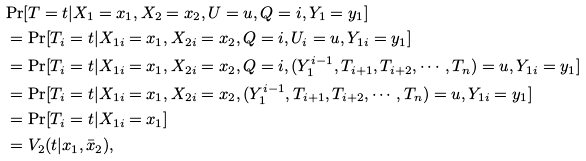<formula> <loc_0><loc_0><loc_500><loc_500>& \text {Pr} [ T = t | X _ { 1 } = x _ { 1 } , X _ { 2 } = x _ { 2 } , U = u , Q = i , Y _ { 1 } = y _ { 1 } ] \\ & = \text {Pr} [ T _ { i } = t | X _ { 1 i } = x _ { 1 } , X _ { 2 i } = x _ { 2 } , Q = i , U _ { i } = u , Y _ { 1 i } = y _ { 1 } ] \\ & = \text {Pr} [ T _ { i } = t | X _ { 1 i } = x _ { 1 } , X _ { 2 i } = x _ { 2 } , Q = i , ( Y _ { 1 } ^ { i - 1 } , T _ { i + 1 } , T _ { i + 2 } , \cdots , T _ { n } ) = u , Y _ { 1 i } = y _ { 1 } ] \\ & = \text {Pr} [ T _ { i } = t | X _ { 1 i } = x _ { 1 } , X _ { 2 i } = x _ { 2 } , ( Y _ { 1 } ^ { i - 1 } , T _ { i + 1 } , T _ { i + 2 } , \cdots , T _ { n } ) = u , Y _ { 1 i } = y _ { 1 } ] \\ & = \text {Pr} [ T _ { i } = t | X _ { 1 i } = x _ { 1 } ] \\ & = V _ { 2 } ( t | x _ { 1 } , \bar { x } _ { 2 } ) ,</formula> 